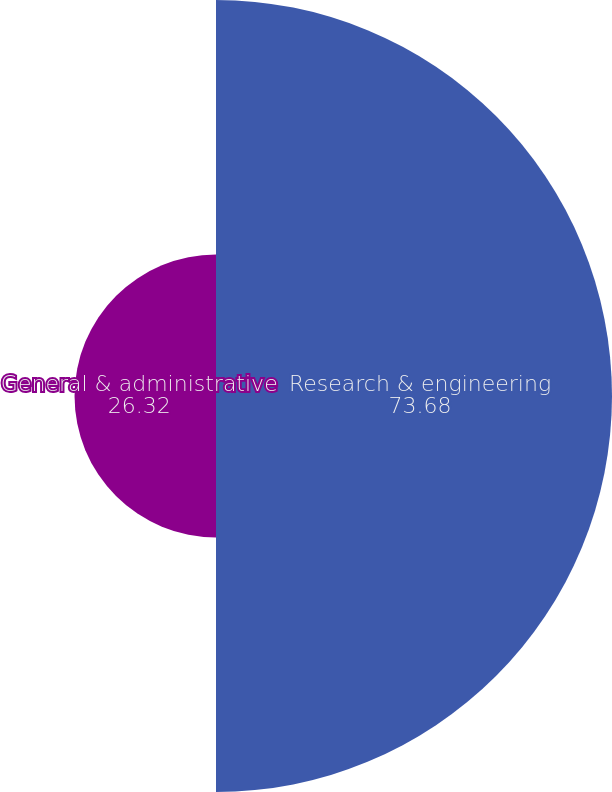<chart> <loc_0><loc_0><loc_500><loc_500><pie_chart><fcel>Research & engineering<fcel>General & administrative<nl><fcel>73.68%<fcel>26.32%<nl></chart> 